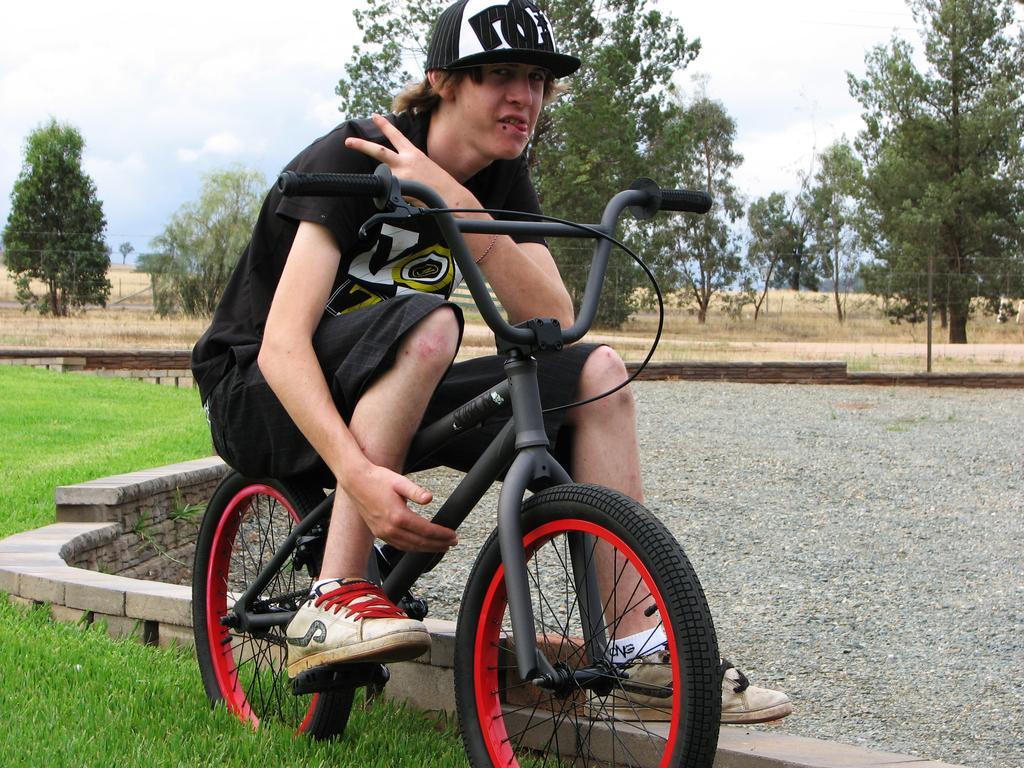Could you give a brief overview of what you see in this image? This picture shows a man seated on the bicycle. He wore a cap on its head and we see grass on the ground and few trees and a cloudy sky. 